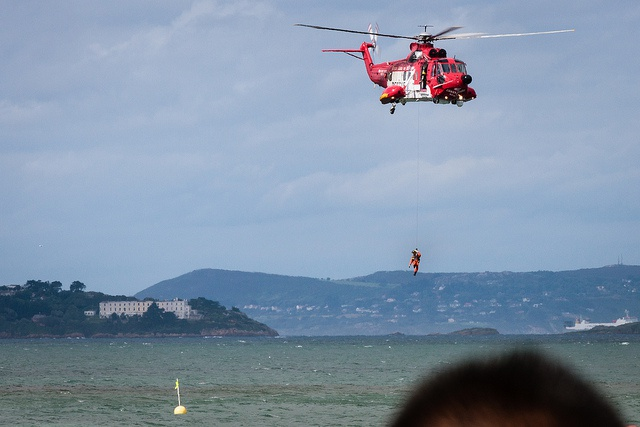Describe the objects in this image and their specific colors. I can see people in darkgray, black, gray, and purple tones and people in darkgray, black, maroon, gray, and brown tones in this image. 